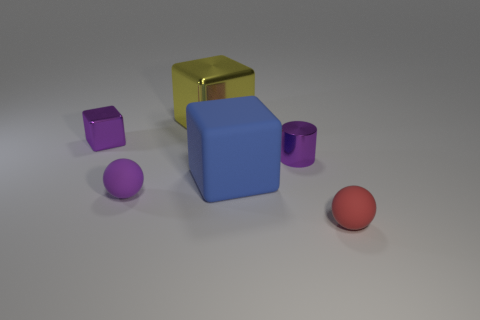Add 2 red rubber balls. How many objects exist? 8 Subtract all cylinders. How many objects are left? 5 Add 4 large yellow blocks. How many large yellow blocks are left? 5 Add 1 metallic objects. How many metallic objects exist? 4 Subtract 0 red blocks. How many objects are left? 6 Subtract all tiny purple metal cubes. Subtract all purple metal things. How many objects are left? 3 